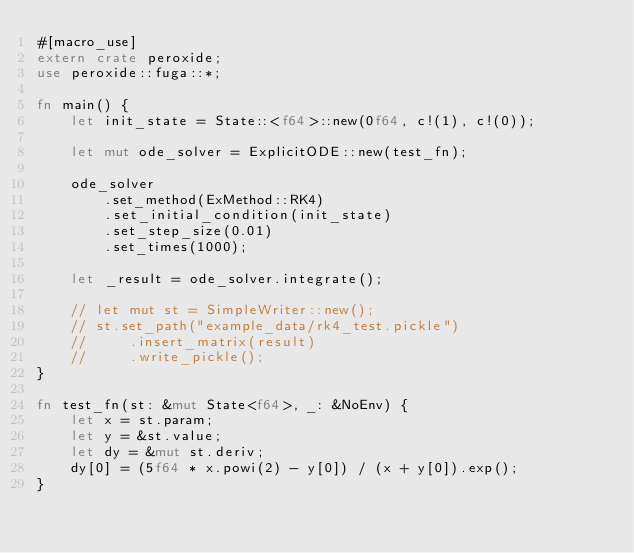<code> <loc_0><loc_0><loc_500><loc_500><_Rust_>#[macro_use]
extern crate peroxide;
use peroxide::fuga::*;

fn main() {
    let init_state = State::<f64>::new(0f64, c!(1), c!(0));

    let mut ode_solver = ExplicitODE::new(test_fn);

    ode_solver
        .set_method(ExMethod::RK4)
        .set_initial_condition(init_state)
        .set_step_size(0.01)
        .set_times(1000);

    let _result = ode_solver.integrate();

    // let mut st = SimpleWriter::new();
    // st.set_path("example_data/rk4_test.pickle")
    //     .insert_matrix(result)
    //     .write_pickle();
}

fn test_fn(st: &mut State<f64>, _: &NoEnv) {
    let x = st.param;
    let y = &st.value;
    let dy = &mut st.deriv;
    dy[0] = (5f64 * x.powi(2) - y[0]) / (x + y[0]).exp();
}
</code> 